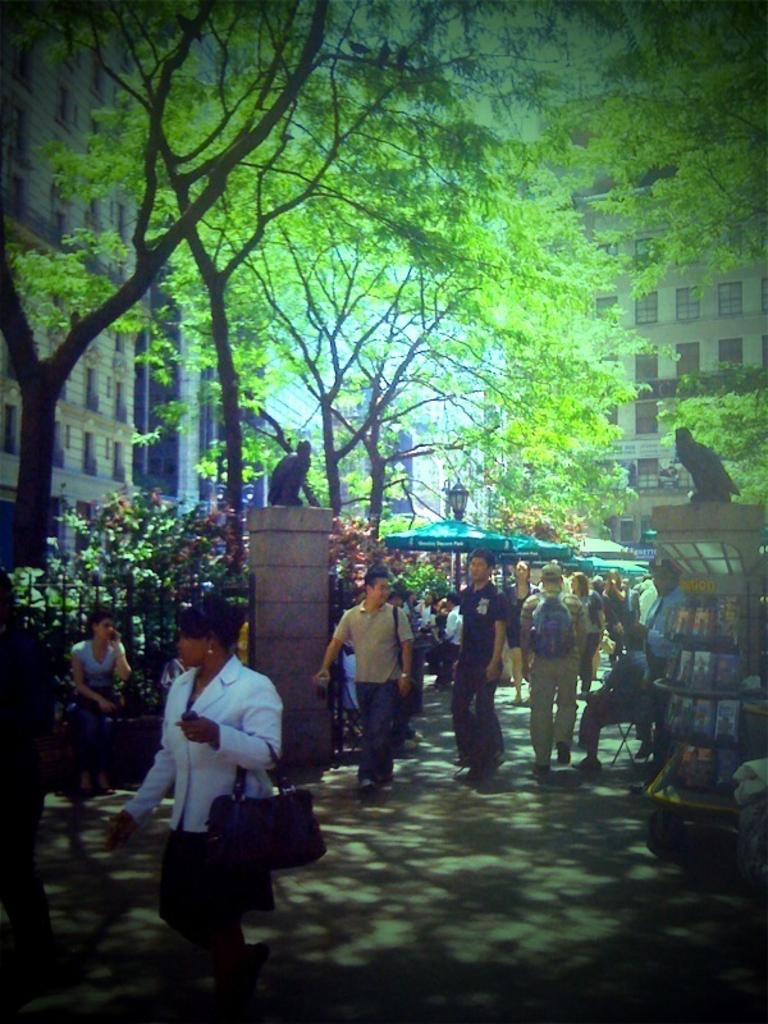What is the main subject of the image? There is a group of people on the ground in the image. What can be seen in the image besides the group of people? There is a fence, pillars with statues, tents, buildings, and trees visible in the image. Can you describe the fence in the image? The fence is a feature that can be seen in the image. What is visible in the background of the image? There are buildings and trees in the background of the image. What type of pets are being used to sew the tents in the image? There are no pets present in the image, and tents are not being sewn. 